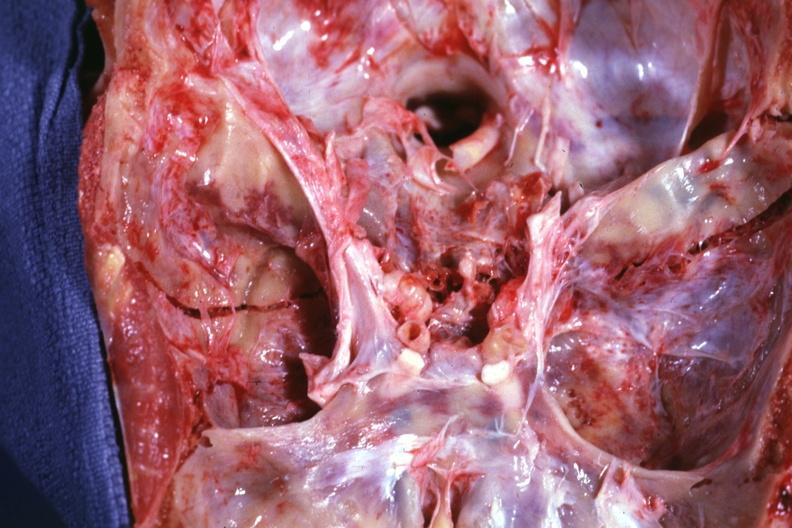what is present?
Answer the question using a single word or phrase. Bone 